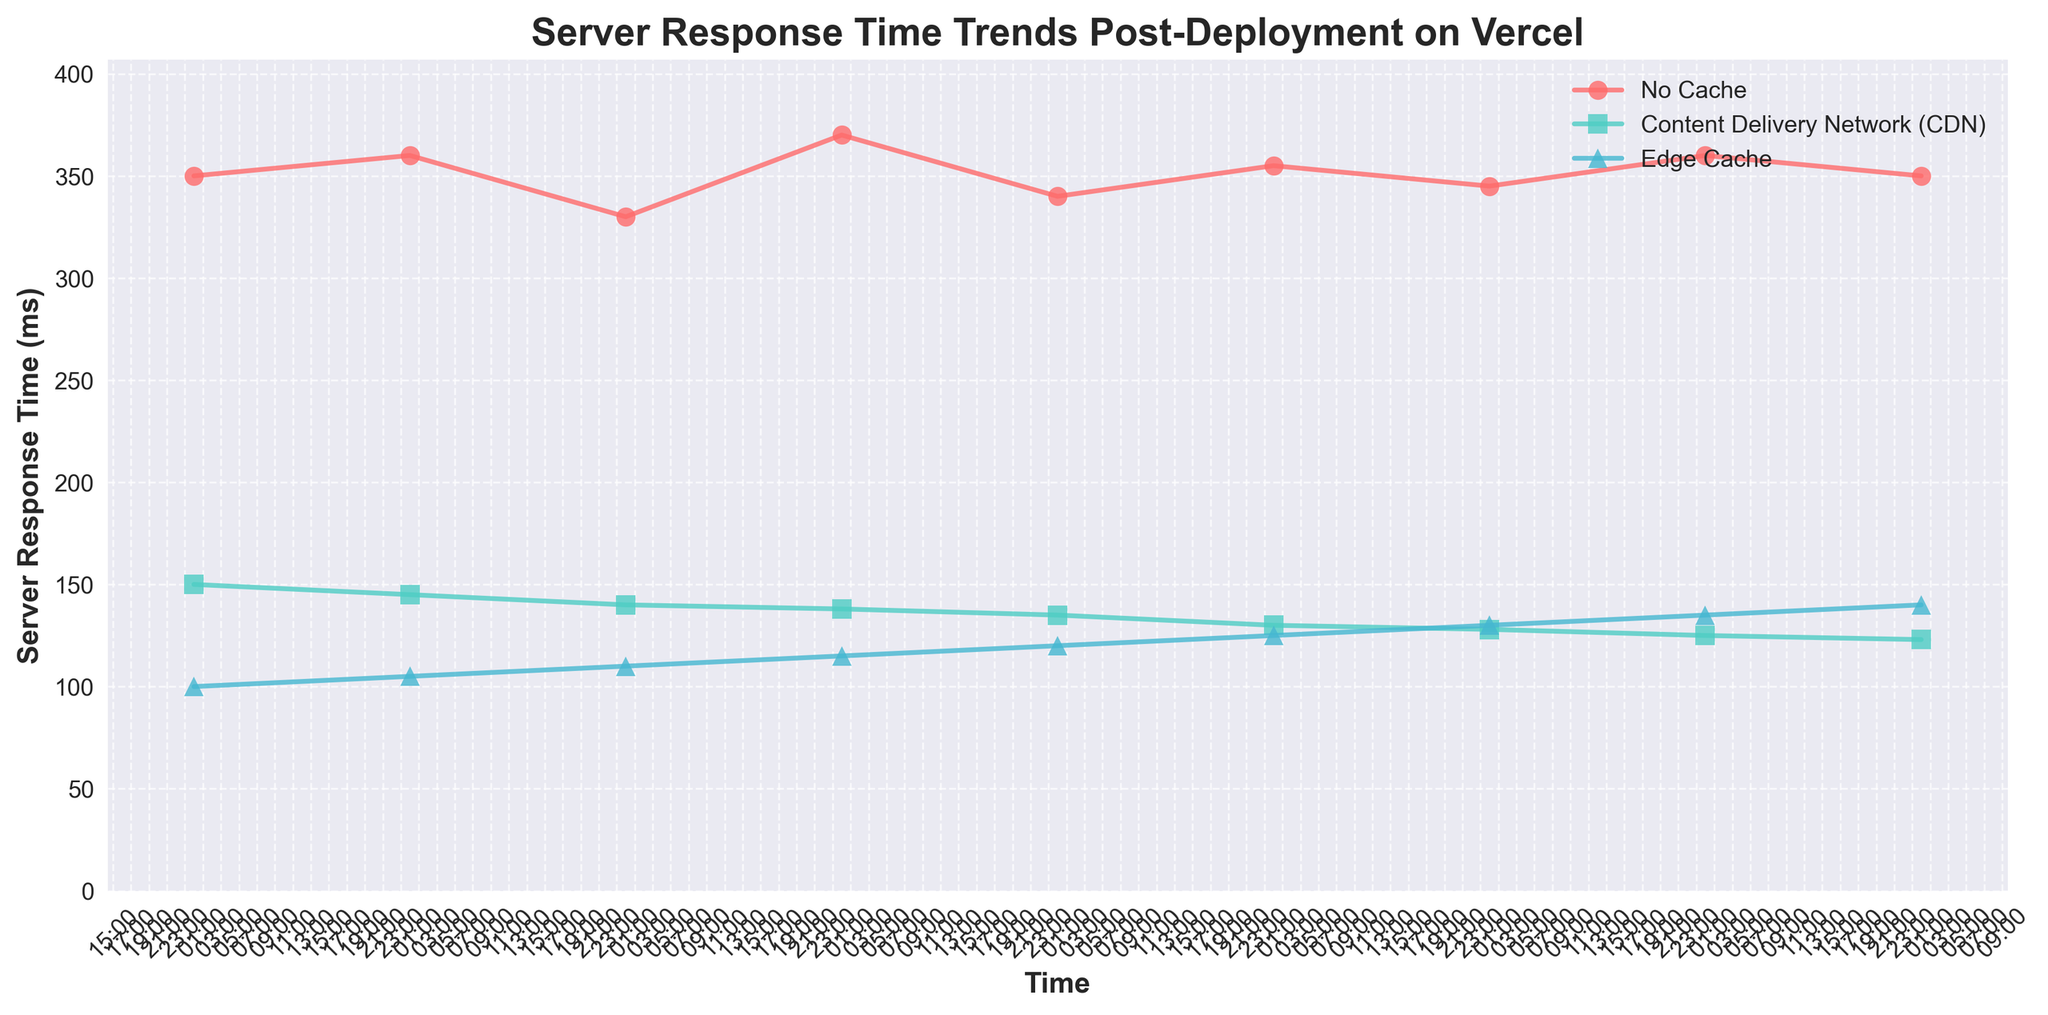What is the title of the plot? The title is written at the top of the plot. It reads "Server Response Time Trends Post-Deployment on Vercel".
Answer: Server Response Time Trends Post-Deployment on Vercel What is the time interval between the major ticks on the x-axis? The major ticks on the x-axis occur every 2 hours, indicated by the labels such as "00:00", "02:00", etc.
Answer: 2 hours At what time was the server response time of the No Cache strategy the highest? Look for the highest point on the line representing the No Cache strategy, which is marked by red circles. This peak occurs at "03:00" with a value of 370 ms.
Answer: 03:00 Which cache strategy had the lowest server response time and at what value? Look at the lowest points of each line in the plot. The Edge Cache strategy, represented by blue triangles, reaches the lowest point at "00:00" with a response time of 100 ms.
Answer: Edge Cache, 100 ms How does the server response time change for the Content Delivery Network (CDN) from 00:00 to 08:00? Observe the green square-marked line from left to right. The response time starts at 150 ms at "00:00" and gradually decreases to 123 ms by "08:00".
Answer: Decreases from 150 ms to 123 ms Which caching strategy shows the most consistent server response time trend? Comparing the lines, the Content Delivery Network (CDN) strategy shows a smoother and more consistent trend compared to the more fluctuating lines of No Cache and Edge Cache.
Answer: Content Delivery Network (CDN) What is the difference in server response time between the No Cache and Edge Cache strategies at 06:00? Find the values for both strategies at "06:00". The No Cache response time is 345 ms, and the Edge Cache response time is 130 ms. The difference is 345 - 130 = 215 ms.
Answer: 215 ms What is the general trend of server response times for the Edge Cache strategy over the observed period? Observe the blue triangle-marked line from left to right. The server response time for Edge Cache generally increases from 100 ms at "00:00" to 140 ms at "08:00".
Answer: Generally increases Which time point shows the smallest difference in server response times between the No Cache and Content Delivery Network (CDN) strategies? Compare the differences at each time point and determine the smallest. At "00:00", the difference is 350 - 150 = 200 ms. At "01:00", the difference is 360 - 145 = 215 ms. At "02:00", the difference is 330 - 140 = 190 ms, which is the smallest difference. The differences for later times are larger.
Answer: 02:00 How does the performance of Edge Cache compare to No Cache over the entire period? Observe and compare the trends of the lines. The Edge Cache strategy consistently has lower response times than the No Cache strategy throughout the entire period.
Answer: Consistently better (lower response times) 